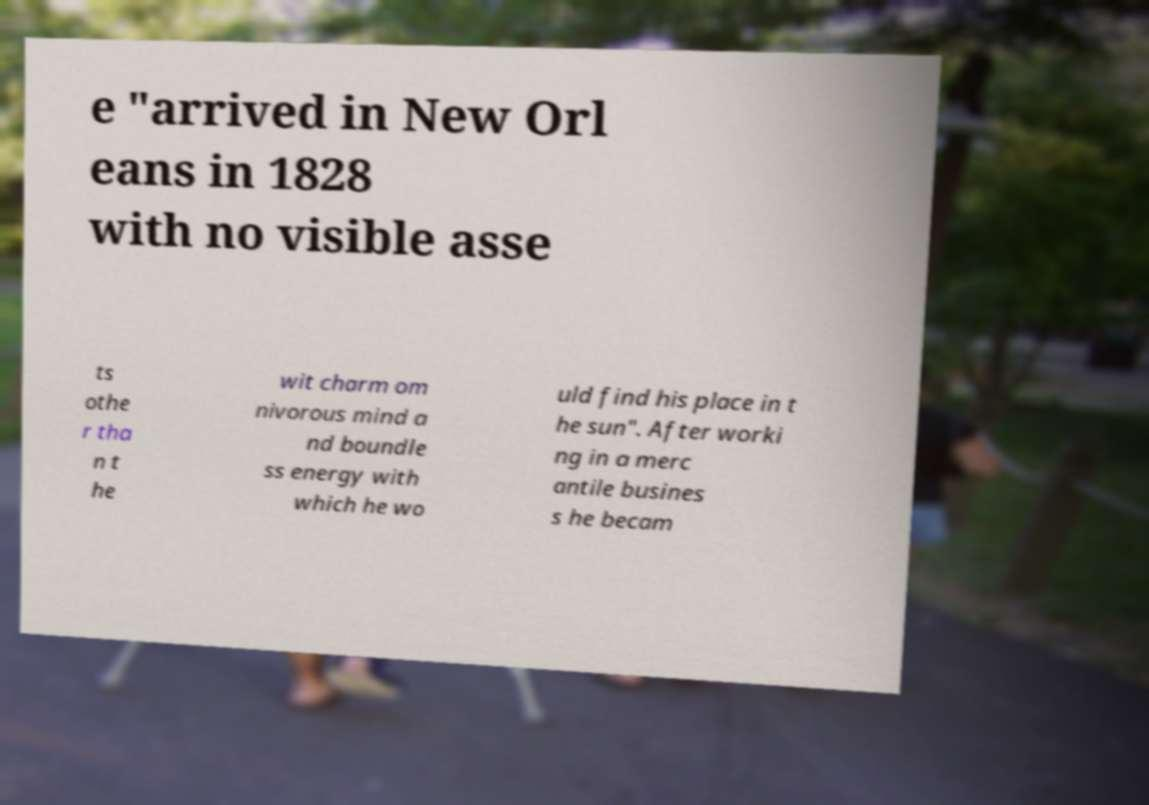Please read and relay the text visible in this image. What does it say? e "arrived in New Orl eans in 1828 with no visible asse ts othe r tha n t he wit charm om nivorous mind a nd boundle ss energy with which he wo uld find his place in t he sun". After worki ng in a merc antile busines s he becam 